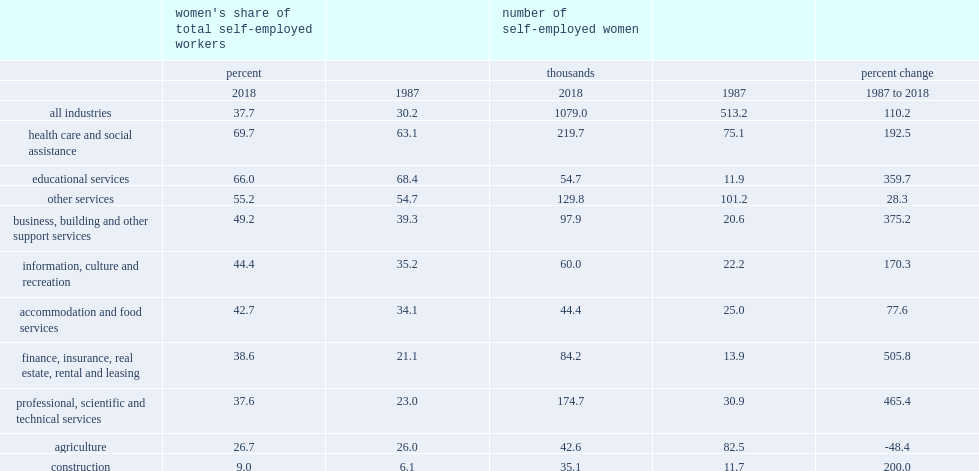As women made inroads in the labour market, what percent of their share of self-employment increased in a number of industries such as professional, scientific and technical services increased between 1987 and 2018? 37.6 23.0. What percent of self-employed women's proportion has changed in the finance, insurance, real estate, rental and leasing services industry between 1987 and 2018? 21.1 38.6. 